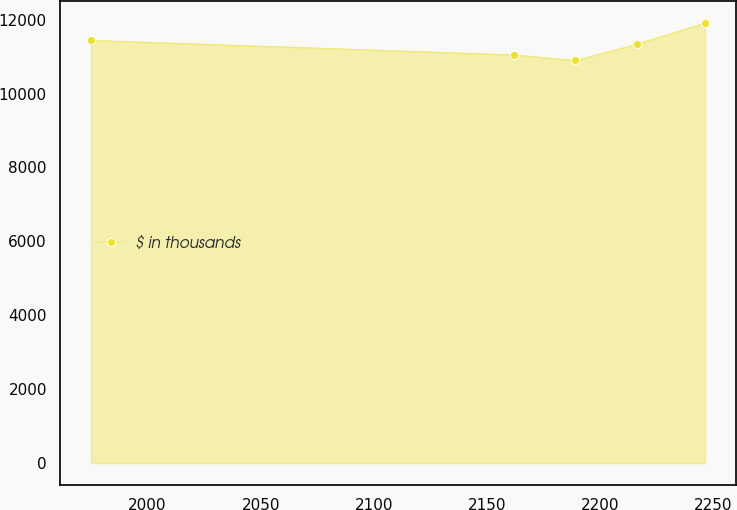Convert chart. <chart><loc_0><loc_0><loc_500><loc_500><line_chart><ecel><fcel>$ in thousands<nl><fcel>1974.97<fcel>11442.5<nl><fcel>2161.92<fcel>11049.8<nl><fcel>2189.05<fcel>10896<nl><fcel>2216.18<fcel>11340.9<nl><fcel>2246.3<fcel>11911.4<nl></chart> 